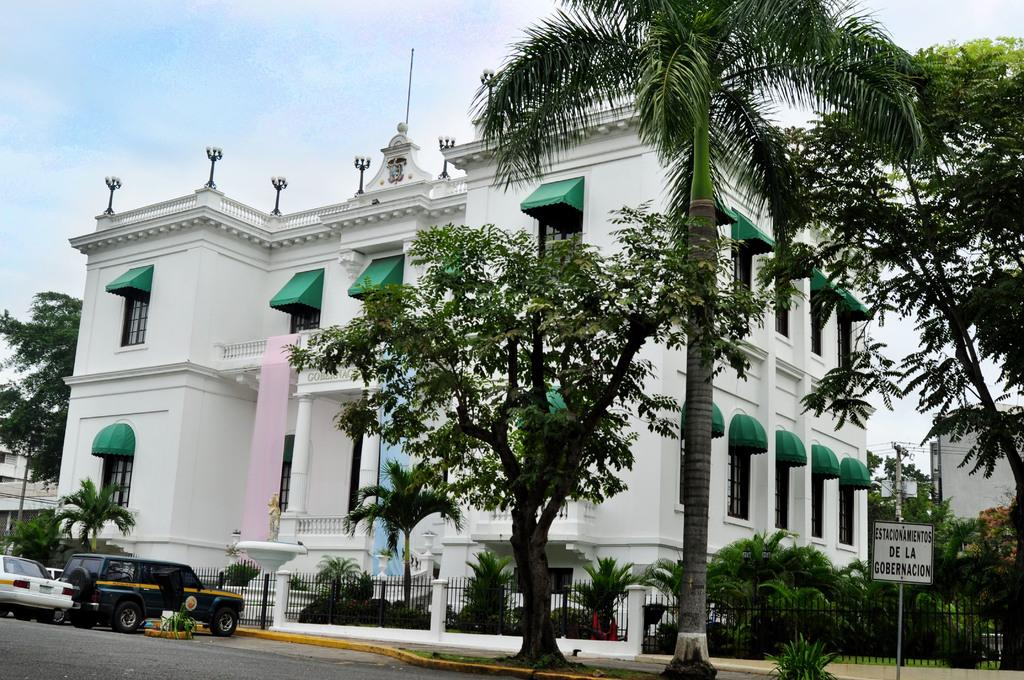What can be seen moving on the road in the image? There are vehicles on the road in the image. What type of natural elements are present in the image? There are plants, trees, and the sky visible in the image. What man-made structures can be seen in the image? There is a board, poles, a fence, and buildings in the image. What is the opinion of the rose in the image? There is no rose present in the image, so it is not possible to determine its opinion. What type of system is being used to control the vehicles on the road in the image? There is no information provided about a system controlling the vehicles in the image. 